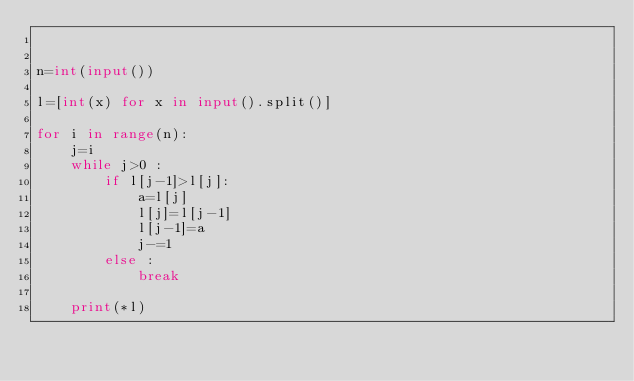Convert code to text. <code><loc_0><loc_0><loc_500><loc_500><_Python_>

n=int(input())

l=[int(x) for x in input().split()]

for i in range(n):
    j=i
    while j>0 :
        if l[j-1]>l[j]:
            a=l[j]
            l[j]=l[j-1]
            l[j-1]=a
            j-=1
        else :
            break

    print(*l)

</code> 